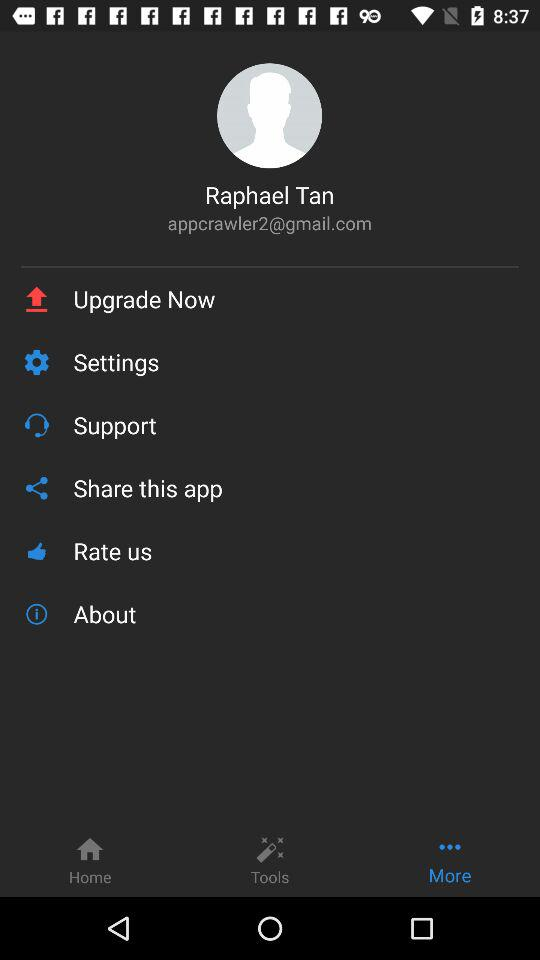What is the user name? The user name is Raphael Tan. 